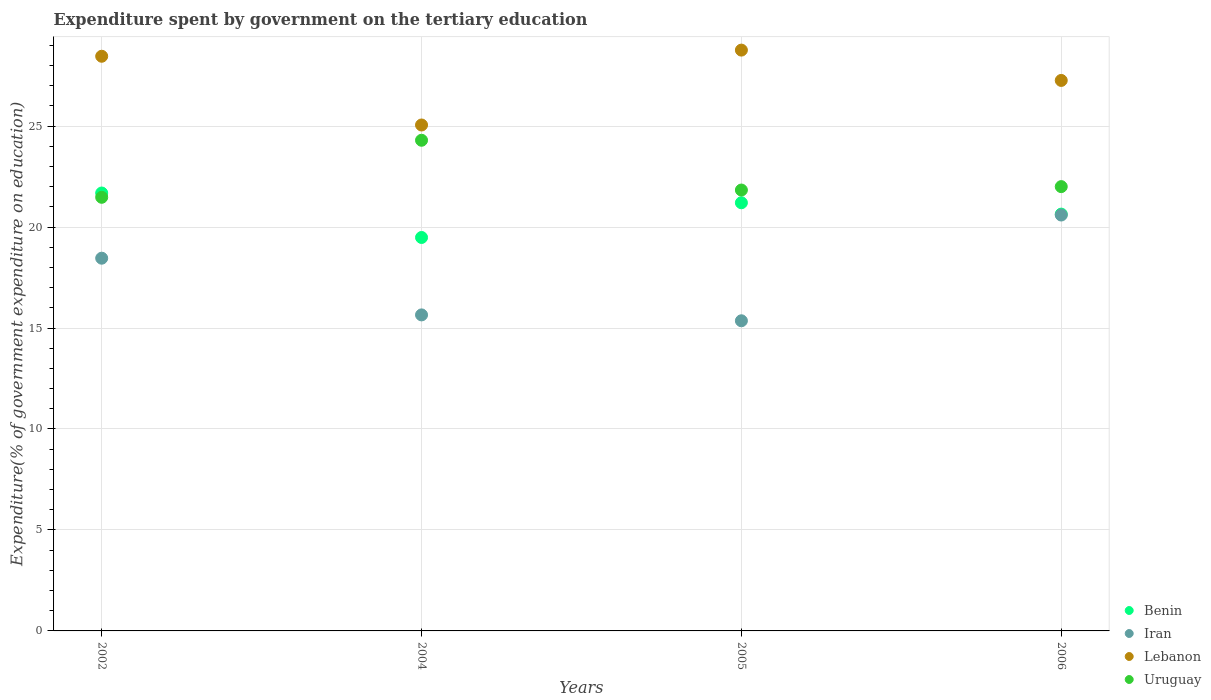How many different coloured dotlines are there?
Your answer should be compact. 4. Is the number of dotlines equal to the number of legend labels?
Give a very brief answer. Yes. What is the expenditure spent by government on the tertiary education in Iran in 2005?
Provide a short and direct response. 15.36. Across all years, what is the maximum expenditure spent by government on the tertiary education in Uruguay?
Your answer should be very brief. 24.3. Across all years, what is the minimum expenditure spent by government on the tertiary education in Lebanon?
Your answer should be very brief. 25.05. In which year was the expenditure spent by government on the tertiary education in Lebanon maximum?
Offer a very short reply. 2005. What is the total expenditure spent by government on the tertiary education in Uruguay in the graph?
Your answer should be very brief. 89.61. What is the difference between the expenditure spent by government on the tertiary education in Benin in 2002 and that in 2006?
Offer a very short reply. 1.04. What is the difference between the expenditure spent by government on the tertiary education in Lebanon in 2004 and the expenditure spent by government on the tertiary education in Benin in 2005?
Make the answer very short. 3.85. What is the average expenditure spent by government on the tertiary education in Uruguay per year?
Ensure brevity in your answer.  22.4. In the year 2004, what is the difference between the expenditure spent by government on the tertiary education in Lebanon and expenditure spent by government on the tertiary education in Benin?
Offer a very short reply. 5.57. What is the ratio of the expenditure spent by government on the tertiary education in Lebanon in 2002 to that in 2006?
Your answer should be very brief. 1.04. Is the difference between the expenditure spent by government on the tertiary education in Lebanon in 2004 and 2005 greater than the difference between the expenditure spent by government on the tertiary education in Benin in 2004 and 2005?
Give a very brief answer. No. What is the difference between the highest and the second highest expenditure spent by government on the tertiary education in Uruguay?
Give a very brief answer. 2.3. What is the difference between the highest and the lowest expenditure spent by government on the tertiary education in Lebanon?
Offer a very short reply. 3.71. In how many years, is the expenditure spent by government on the tertiary education in Lebanon greater than the average expenditure spent by government on the tertiary education in Lebanon taken over all years?
Make the answer very short. 2. Is the sum of the expenditure spent by government on the tertiary education in Iran in 2002 and 2004 greater than the maximum expenditure spent by government on the tertiary education in Uruguay across all years?
Ensure brevity in your answer.  Yes. Is it the case that in every year, the sum of the expenditure spent by government on the tertiary education in Uruguay and expenditure spent by government on the tertiary education in Iran  is greater than the sum of expenditure spent by government on the tertiary education in Lebanon and expenditure spent by government on the tertiary education in Benin?
Offer a very short reply. No. Is the expenditure spent by government on the tertiary education in Lebanon strictly less than the expenditure spent by government on the tertiary education in Iran over the years?
Offer a terse response. No. Where does the legend appear in the graph?
Give a very brief answer. Bottom right. How are the legend labels stacked?
Make the answer very short. Vertical. What is the title of the graph?
Your response must be concise. Expenditure spent by government on the tertiary education. Does "Guinea" appear as one of the legend labels in the graph?
Offer a terse response. No. What is the label or title of the X-axis?
Provide a short and direct response. Years. What is the label or title of the Y-axis?
Provide a succinct answer. Expenditure(% of government expenditure on education). What is the Expenditure(% of government expenditure on education) in Benin in 2002?
Offer a very short reply. 21.69. What is the Expenditure(% of government expenditure on education) in Iran in 2002?
Your response must be concise. 18.46. What is the Expenditure(% of government expenditure on education) of Lebanon in 2002?
Provide a short and direct response. 28.46. What is the Expenditure(% of government expenditure on education) in Uruguay in 2002?
Make the answer very short. 21.47. What is the Expenditure(% of government expenditure on education) of Benin in 2004?
Keep it short and to the point. 19.48. What is the Expenditure(% of government expenditure on education) in Iran in 2004?
Your answer should be very brief. 15.65. What is the Expenditure(% of government expenditure on education) in Lebanon in 2004?
Provide a short and direct response. 25.05. What is the Expenditure(% of government expenditure on education) in Uruguay in 2004?
Offer a terse response. 24.3. What is the Expenditure(% of government expenditure on education) in Benin in 2005?
Your response must be concise. 21.2. What is the Expenditure(% of government expenditure on education) in Iran in 2005?
Your answer should be very brief. 15.36. What is the Expenditure(% of government expenditure on education) of Lebanon in 2005?
Your answer should be compact. 28.76. What is the Expenditure(% of government expenditure on education) of Uruguay in 2005?
Offer a very short reply. 21.83. What is the Expenditure(% of government expenditure on education) of Benin in 2006?
Make the answer very short. 20.64. What is the Expenditure(% of government expenditure on education) in Iran in 2006?
Your answer should be very brief. 20.6. What is the Expenditure(% of government expenditure on education) of Lebanon in 2006?
Your response must be concise. 27.26. What is the Expenditure(% of government expenditure on education) of Uruguay in 2006?
Make the answer very short. 22. Across all years, what is the maximum Expenditure(% of government expenditure on education) of Benin?
Your answer should be compact. 21.69. Across all years, what is the maximum Expenditure(% of government expenditure on education) in Iran?
Ensure brevity in your answer.  20.6. Across all years, what is the maximum Expenditure(% of government expenditure on education) in Lebanon?
Make the answer very short. 28.76. Across all years, what is the maximum Expenditure(% of government expenditure on education) in Uruguay?
Your response must be concise. 24.3. Across all years, what is the minimum Expenditure(% of government expenditure on education) in Benin?
Provide a short and direct response. 19.48. Across all years, what is the minimum Expenditure(% of government expenditure on education) of Iran?
Offer a very short reply. 15.36. Across all years, what is the minimum Expenditure(% of government expenditure on education) in Lebanon?
Your answer should be very brief. 25.05. Across all years, what is the minimum Expenditure(% of government expenditure on education) in Uruguay?
Ensure brevity in your answer.  21.47. What is the total Expenditure(% of government expenditure on education) in Benin in the graph?
Ensure brevity in your answer.  83.01. What is the total Expenditure(% of government expenditure on education) of Iran in the graph?
Provide a short and direct response. 70.06. What is the total Expenditure(% of government expenditure on education) of Lebanon in the graph?
Offer a very short reply. 109.54. What is the total Expenditure(% of government expenditure on education) of Uruguay in the graph?
Your answer should be compact. 89.61. What is the difference between the Expenditure(% of government expenditure on education) of Benin in 2002 and that in 2004?
Keep it short and to the point. 2.2. What is the difference between the Expenditure(% of government expenditure on education) in Iran in 2002 and that in 2004?
Provide a short and direct response. 2.81. What is the difference between the Expenditure(% of government expenditure on education) in Lebanon in 2002 and that in 2004?
Ensure brevity in your answer.  3.4. What is the difference between the Expenditure(% of government expenditure on education) in Uruguay in 2002 and that in 2004?
Your response must be concise. -2.82. What is the difference between the Expenditure(% of government expenditure on education) of Benin in 2002 and that in 2005?
Keep it short and to the point. 0.48. What is the difference between the Expenditure(% of government expenditure on education) of Iran in 2002 and that in 2005?
Provide a succinct answer. 3.1. What is the difference between the Expenditure(% of government expenditure on education) in Lebanon in 2002 and that in 2005?
Offer a very short reply. -0.3. What is the difference between the Expenditure(% of government expenditure on education) of Uruguay in 2002 and that in 2005?
Your response must be concise. -0.36. What is the difference between the Expenditure(% of government expenditure on education) of Benin in 2002 and that in 2006?
Keep it short and to the point. 1.04. What is the difference between the Expenditure(% of government expenditure on education) of Iran in 2002 and that in 2006?
Your answer should be very brief. -2.14. What is the difference between the Expenditure(% of government expenditure on education) of Lebanon in 2002 and that in 2006?
Your answer should be compact. 1.2. What is the difference between the Expenditure(% of government expenditure on education) of Uruguay in 2002 and that in 2006?
Offer a terse response. -0.53. What is the difference between the Expenditure(% of government expenditure on education) in Benin in 2004 and that in 2005?
Offer a terse response. -1.72. What is the difference between the Expenditure(% of government expenditure on education) of Iran in 2004 and that in 2005?
Your response must be concise. 0.29. What is the difference between the Expenditure(% of government expenditure on education) of Lebanon in 2004 and that in 2005?
Offer a terse response. -3.71. What is the difference between the Expenditure(% of government expenditure on education) of Uruguay in 2004 and that in 2005?
Give a very brief answer. 2.47. What is the difference between the Expenditure(% of government expenditure on education) of Benin in 2004 and that in 2006?
Your answer should be compact. -1.16. What is the difference between the Expenditure(% of government expenditure on education) of Iran in 2004 and that in 2006?
Your response must be concise. -4.95. What is the difference between the Expenditure(% of government expenditure on education) of Lebanon in 2004 and that in 2006?
Ensure brevity in your answer.  -2.21. What is the difference between the Expenditure(% of government expenditure on education) of Uruguay in 2004 and that in 2006?
Offer a terse response. 2.3. What is the difference between the Expenditure(% of government expenditure on education) of Benin in 2005 and that in 2006?
Keep it short and to the point. 0.56. What is the difference between the Expenditure(% of government expenditure on education) in Iran in 2005 and that in 2006?
Your answer should be very brief. -5.24. What is the difference between the Expenditure(% of government expenditure on education) of Lebanon in 2005 and that in 2006?
Provide a short and direct response. 1.5. What is the difference between the Expenditure(% of government expenditure on education) in Uruguay in 2005 and that in 2006?
Your answer should be very brief. -0.17. What is the difference between the Expenditure(% of government expenditure on education) of Benin in 2002 and the Expenditure(% of government expenditure on education) of Iran in 2004?
Your answer should be very brief. 6.04. What is the difference between the Expenditure(% of government expenditure on education) of Benin in 2002 and the Expenditure(% of government expenditure on education) of Lebanon in 2004?
Keep it short and to the point. -3.37. What is the difference between the Expenditure(% of government expenditure on education) of Benin in 2002 and the Expenditure(% of government expenditure on education) of Uruguay in 2004?
Ensure brevity in your answer.  -2.61. What is the difference between the Expenditure(% of government expenditure on education) in Iran in 2002 and the Expenditure(% of government expenditure on education) in Lebanon in 2004?
Provide a short and direct response. -6.6. What is the difference between the Expenditure(% of government expenditure on education) of Iran in 2002 and the Expenditure(% of government expenditure on education) of Uruguay in 2004?
Make the answer very short. -5.84. What is the difference between the Expenditure(% of government expenditure on education) in Lebanon in 2002 and the Expenditure(% of government expenditure on education) in Uruguay in 2004?
Offer a very short reply. 4.16. What is the difference between the Expenditure(% of government expenditure on education) in Benin in 2002 and the Expenditure(% of government expenditure on education) in Iran in 2005?
Your answer should be compact. 6.33. What is the difference between the Expenditure(% of government expenditure on education) in Benin in 2002 and the Expenditure(% of government expenditure on education) in Lebanon in 2005?
Make the answer very short. -7.08. What is the difference between the Expenditure(% of government expenditure on education) in Benin in 2002 and the Expenditure(% of government expenditure on education) in Uruguay in 2005?
Offer a very short reply. -0.15. What is the difference between the Expenditure(% of government expenditure on education) of Iran in 2002 and the Expenditure(% of government expenditure on education) of Lebanon in 2005?
Your response must be concise. -10.3. What is the difference between the Expenditure(% of government expenditure on education) in Iran in 2002 and the Expenditure(% of government expenditure on education) in Uruguay in 2005?
Keep it short and to the point. -3.38. What is the difference between the Expenditure(% of government expenditure on education) of Lebanon in 2002 and the Expenditure(% of government expenditure on education) of Uruguay in 2005?
Ensure brevity in your answer.  6.62. What is the difference between the Expenditure(% of government expenditure on education) of Benin in 2002 and the Expenditure(% of government expenditure on education) of Iran in 2006?
Keep it short and to the point. 1.09. What is the difference between the Expenditure(% of government expenditure on education) of Benin in 2002 and the Expenditure(% of government expenditure on education) of Lebanon in 2006?
Keep it short and to the point. -5.58. What is the difference between the Expenditure(% of government expenditure on education) in Benin in 2002 and the Expenditure(% of government expenditure on education) in Uruguay in 2006?
Ensure brevity in your answer.  -0.32. What is the difference between the Expenditure(% of government expenditure on education) in Iran in 2002 and the Expenditure(% of government expenditure on education) in Lebanon in 2006?
Keep it short and to the point. -8.8. What is the difference between the Expenditure(% of government expenditure on education) of Iran in 2002 and the Expenditure(% of government expenditure on education) of Uruguay in 2006?
Keep it short and to the point. -3.54. What is the difference between the Expenditure(% of government expenditure on education) of Lebanon in 2002 and the Expenditure(% of government expenditure on education) of Uruguay in 2006?
Provide a short and direct response. 6.46. What is the difference between the Expenditure(% of government expenditure on education) in Benin in 2004 and the Expenditure(% of government expenditure on education) in Iran in 2005?
Your response must be concise. 4.13. What is the difference between the Expenditure(% of government expenditure on education) of Benin in 2004 and the Expenditure(% of government expenditure on education) of Lebanon in 2005?
Make the answer very short. -9.28. What is the difference between the Expenditure(% of government expenditure on education) of Benin in 2004 and the Expenditure(% of government expenditure on education) of Uruguay in 2005?
Give a very brief answer. -2.35. What is the difference between the Expenditure(% of government expenditure on education) in Iran in 2004 and the Expenditure(% of government expenditure on education) in Lebanon in 2005?
Keep it short and to the point. -13.11. What is the difference between the Expenditure(% of government expenditure on education) in Iran in 2004 and the Expenditure(% of government expenditure on education) in Uruguay in 2005?
Provide a short and direct response. -6.18. What is the difference between the Expenditure(% of government expenditure on education) in Lebanon in 2004 and the Expenditure(% of government expenditure on education) in Uruguay in 2005?
Offer a very short reply. 3.22. What is the difference between the Expenditure(% of government expenditure on education) of Benin in 2004 and the Expenditure(% of government expenditure on education) of Iran in 2006?
Keep it short and to the point. -1.11. What is the difference between the Expenditure(% of government expenditure on education) of Benin in 2004 and the Expenditure(% of government expenditure on education) of Lebanon in 2006?
Give a very brief answer. -7.78. What is the difference between the Expenditure(% of government expenditure on education) in Benin in 2004 and the Expenditure(% of government expenditure on education) in Uruguay in 2006?
Make the answer very short. -2.52. What is the difference between the Expenditure(% of government expenditure on education) in Iran in 2004 and the Expenditure(% of government expenditure on education) in Lebanon in 2006?
Keep it short and to the point. -11.61. What is the difference between the Expenditure(% of government expenditure on education) of Iran in 2004 and the Expenditure(% of government expenditure on education) of Uruguay in 2006?
Provide a short and direct response. -6.35. What is the difference between the Expenditure(% of government expenditure on education) in Lebanon in 2004 and the Expenditure(% of government expenditure on education) in Uruguay in 2006?
Offer a very short reply. 3.05. What is the difference between the Expenditure(% of government expenditure on education) in Benin in 2005 and the Expenditure(% of government expenditure on education) in Iran in 2006?
Ensure brevity in your answer.  0.61. What is the difference between the Expenditure(% of government expenditure on education) in Benin in 2005 and the Expenditure(% of government expenditure on education) in Lebanon in 2006?
Give a very brief answer. -6.06. What is the difference between the Expenditure(% of government expenditure on education) in Benin in 2005 and the Expenditure(% of government expenditure on education) in Uruguay in 2006?
Provide a short and direct response. -0.8. What is the difference between the Expenditure(% of government expenditure on education) in Iran in 2005 and the Expenditure(% of government expenditure on education) in Lebanon in 2006?
Keep it short and to the point. -11.9. What is the difference between the Expenditure(% of government expenditure on education) in Iran in 2005 and the Expenditure(% of government expenditure on education) in Uruguay in 2006?
Your response must be concise. -6.64. What is the difference between the Expenditure(% of government expenditure on education) of Lebanon in 2005 and the Expenditure(% of government expenditure on education) of Uruguay in 2006?
Provide a succinct answer. 6.76. What is the average Expenditure(% of government expenditure on education) in Benin per year?
Offer a very short reply. 20.75. What is the average Expenditure(% of government expenditure on education) of Iran per year?
Make the answer very short. 17.52. What is the average Expenditure(% of government expenditure on education) of Lebanon per year?
Keep it short and to the point. 27.38. What is the average Expenditure(% of government expenditure on education) of Uruguay per year?
Your answer should be compact. 22.4. In the year 2002, what is the difference between the Expenditure(% of government expenditure on education) of Benin and Expenditure(% of government expenditure on education) of Iran?
Ensure brevity in your answer.  3.23. In the year 2002, what is the difference between the Expenditure(% of government expenditure on education) in Benin and Expenditure(% of government expenditure on education) in Lebanon?
Provide a short and direct response. -6.77. In the year 2002, what is the difference between the Expenditure(% of government expenditure on education) in Benin and Expenditure(% of government expenditure on education) in Uruguay?
Make the answer very short. 0.21. In the year 2002, what is the difference between the Expenditure(% of government expenditure on education) in Iran and Expenditure(% of government expenditure on education) in Lebanon?
Give a very brief answer. -10. In the year 2002, what is the difference between the Expenditure(% of government expenditure on education) of Iran and Expenditure(% of government expenditure on education) of Uruguay?
Provide a succinct answer. -3.02. In the year 2002, what is the difference between the Expenditure(% of government expenditure on education) in Lebanon and Expenditure(% of government expenditure on education) in Uruguay?
Provide a succinct answer. 6.98. In the year 2004, what is the difference between the Expenditure(% of government expenditure on education) of Benin and Expenditure(% of government expenditure on education) of Iran?
Offer a very short reply. 3.83. In the year 2004, what is the difference between the Expenditure(% of government expenditure on education) in Benin and Expenditure(% of government expenditure on education) in Lebanon?
Provide a short and direct response. -5.57. In the year 2004, what is the difference between the Expenditure(% of government expenditure on education) in Benin and Expenditure(% of government expenditure on education) in Uruguay?
Provide a short and direct response. -4.81. In the year 2004, what is the difference between the Expenditure(% of government expenditure on education) in Iran and Expenditure(% of government expenditure on education) in Lebanon?
Make the answer very short. -9.4. In the year 2004, what is the difference between the Expenditure(% of government expenditure on education) of Iran and Expenditure(% of government expenditure on education) of Uruguay?
Keep it short and to the point. -8.65. In the year 2004, what is the difference between the Expenditure(% of government expenditure on education) in Lebanon and Expenditure(% of government expenditure on education) in Uruguay?
Your response must be concise. 0.76. In the year 2005, what is the difference between the Expenditure(% of government expenditure on education) of Benin and Expenditure(% of government expenditure on education) of Iran?
Ensure brevity in your answer.  5.84. In the year 2005, what is the difference between the Expenditure(% of government expenditure on education) of Benin and Expenditure(% of government expenditure on education) of Lebanon?
Offer a terse response. -7.56. In the year 2005, what is the difference between the Expenditure(% of government expenditure on education) of Benin and Expenditure(% of government expenditure on education) of Uruguay?
Keep it short and to the point. -0.63. In the year 2005, what is the difference between the Expenditure(% of government expenditure on education) of Iran and Expenditure(% of government expenditure on education) of Lebanon?
Offer a terse response. -13.4. In the year 2005, what is the difference between the Expenditure(% of government expenditure on education) in Iran and Expenditure(% of government expenditure on education) in Uruguay?
Your answer should be compact. -6.47. In the year 2005, what is the difference between the Expenditure(% of government expenditure on education) of Lebanon and Expenditure(% of government expenditure on education) of Uruguay?
Make the answer very short. 6.93. In the year 2006, what is the difference between the Expenditure(% of government expenditure on education) in Benin and Expenditure(% of government expenditure on education) in Iran?
Keep it short and to the point. 0.05. In the year 2006, what is the difference between the Expenditure(% of government expenditure on education) in Benin and Expenditure(% of government expenditure on education) in Lebanon?
Your response must be concise. -6.62. In the year 2006, what is the difference between the Expenditure(% of government expenditure on education) of Benin and Expenditure(% of government expenditure on education) of Uruguay?
Give a very brief answer. -1.36. In the year 2006, what is the difference between the Expenditure(% of government expenditure on education) of Iran and Expenditure(% of government expenditure on education) of Lebanon?
Provide a short and direct response. -6.67. In the year 2006, what is the difference between the Expenditure(% of government expenditure on education) in Iran and Expenditure(% of government expenditure on education) in Uruguay?
Offer a terse response. -1.41. In the year 2006, what is the difference between the Expenditure(% of government expenditure on education) of Lebanon and Expenditure(% of government expenditure on education) of Uruguay?
Keep it short and to the point. 5.26. What is the ratio of the Expenditure(% of government expenditure on education) of Benin in 2002 to that in 2004?
Give a very brief answer. 1.11. What is the ratio of the Expenditure(% of government expenditure on education) in Iran in 2002 to that in 2004?
Your answer should be very brief. 1.18. What is the ratio of the Expenditure(% of government expenditure on education) in Lebanon in 2002 to that in 2004?
Keep it short and to the point. 1.14. What is the ratio of the Expenditure(% of government expenditure on education) in Uruguay in 2002 to that in 2004?
Make the answer very short. 0.88. What is the ratio of the Expenditure(% of government expenditure on education) in Benin in 2002 to that in 2005?
Give a very brief answer. 1.02. What is the ratio of the Expenditure(% of government expenditure on education) in Iran in 2002 to that in 2005?
Your answer should be compact. 1.2. What is the ratio of the Expenditure(% of government expenditure on education) of Uruguay in 2002 to that in 2005?
Provide a succinct answer. 0.98. What is the ratio of the Expenditure(% of government expenditure on education) in Benin in 2002 to that in 2006?
Offer a very short reply. 1.05. What is the ratio of the Expenditure(% of government expenditure on education) in Iran in 2002 to that in 2006?
Your answer should be very brief. 0.9. What is the ratio of the Expenditure(% of government expenditure on education) of Lebanon in 2002 to that in 2006?
Make the answer very short. 1.04. What is the ratio of the Expenditure(% of government expenditure on education) in Benin in 2004 to that in 2005?
Offer a terse response. 0.92. What is the ratio of the Expenditure(% of government expenditure on education) of Lebanon in 2004 to that in 2005?
Make the answer very short. 0.87. What is the ratio of the Expenditure(% of government expenditure on education) in Uruguay in 2004 to that in 2005?
Provide a short and direct response. 1.11. What is the ratio of the Expenditure(% of government expenditure on education) of Benin in 2004 to that in 2006?
Offer a very short reply. 0.94. What is the ratio of the Expenditure(% of government expenditure on education) of Iran in 2004 to that in 2006?
Provide a short and direct response. 0.76. What is the ratio of the Expenditure(% of government expenditure on education) in Lebanon in 2004 to that in 2006?
Provide a short and direct response. 0.92. What is the ratio of the Expenditure(% of government expenditure on education) of Uruguay in 2004 to that in 2006?
Provide a succinct answer. 1.1. What is the ratio of the Expenditure(% of government expenditure on education) of Benin in 2005 to that in 2006?
Provide a short and direct response. 1.03. What is the ratio of the Expenditure(% of government expenditure on education) in Iran in 2005 to that in 2006?
Your answer should be very brief. 0.75. What is the ratio of the Expenditure(% of government expenditure on education) of Lebanon in 2005 to that in 2006?
Keep it short and to the point. 1.06. What is the difference between the highest and the second highest Expenditure(% of government expenditure on education) in Benin?
Keep it short and to the point. 0.48. What is the difference between the highest and the second highest Expenditure(% of government expenditure on education) of Iran?
Make the answer very short. 2.14. What is the difference between the highest and the second highest Expenditure(% of government expenditure on education) of Lebanon?
Offer a terse response. 0.3. What is the difference between the highest and the second highest Expenditure(% of government expenditure on education) in Uruguay?
Your response must be concise. 2.3. What is the difference between the highest and the lowest Expenditure(% of government expenditure on education) in Benin?
Provide a short and direct response. 2.2. What is the difference between the highest and the lowest Expenditure(% of government expenditure on education) in Iran?
Give a very brief answer. 5.24. What is the difference between the highest and the lowest Expenditure(% of government expenditure on education) in Lebanon?
Provide a succinct answer. 3.71. What is the difference between the highest and the lowest Expenditure(% of government expenditure on education) in Uruguay?
Your answer should be compact. 2.82. 